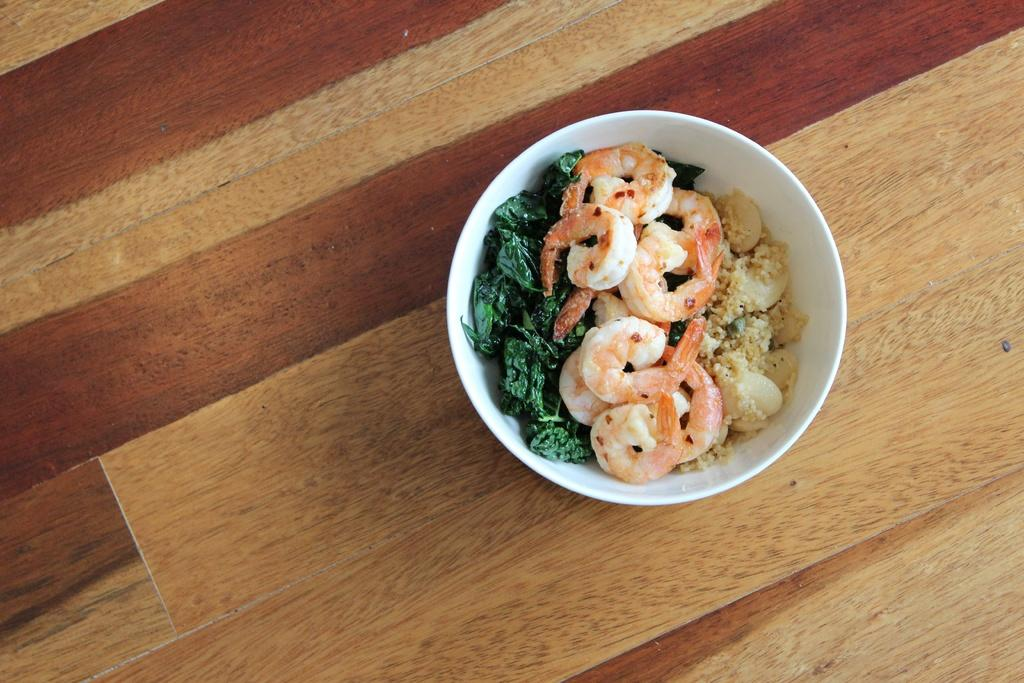What is in the bowl that is visible in the image? The bowl contains leafy vegetables and prawns. What type of food is present in the bowl? The bowl contains leafy vegetables and prawns, which are both ingredients for a dish. Can you describe the contents of the bowl in more detail? The bowl contains leafy vegetables, such as lettuce or spinach, and prawns, which are a type of seafood. How many chairs are visible in the image? There are no chairs present in the image; it only shows a bowl with leafy vegetables and prawns. What type of heart is visible in the image? There is no heart present in the image; it only shows a bowl with leafy vegetables and prawns. 